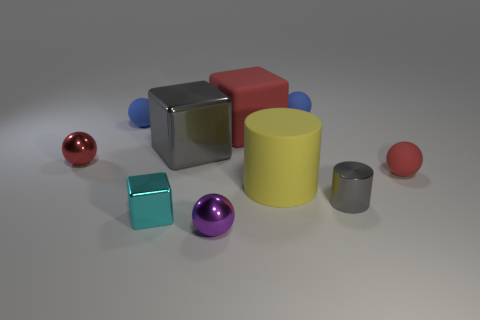If we were to create a pattern using the objects in the image, which color or shape would dominate the pattern? If we base our pattern on color replication, the red objects could dominate due to their vivid hue that stands out. However, if we focus on shape repetition, spheres and cubes would be prevalent since they are the most common forms in the image, providing a structure for a visually cohesive pattern. 